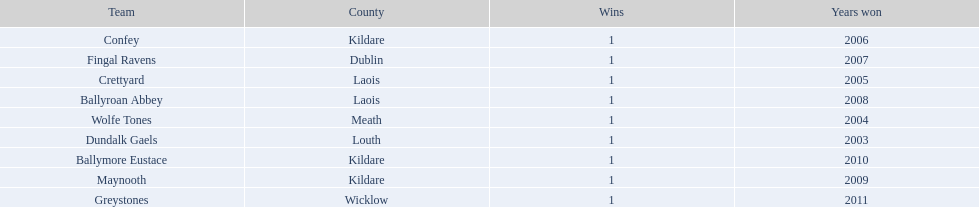What county is the team that won in 2009 from? Kildare. What is the teams name? Maynooth. 